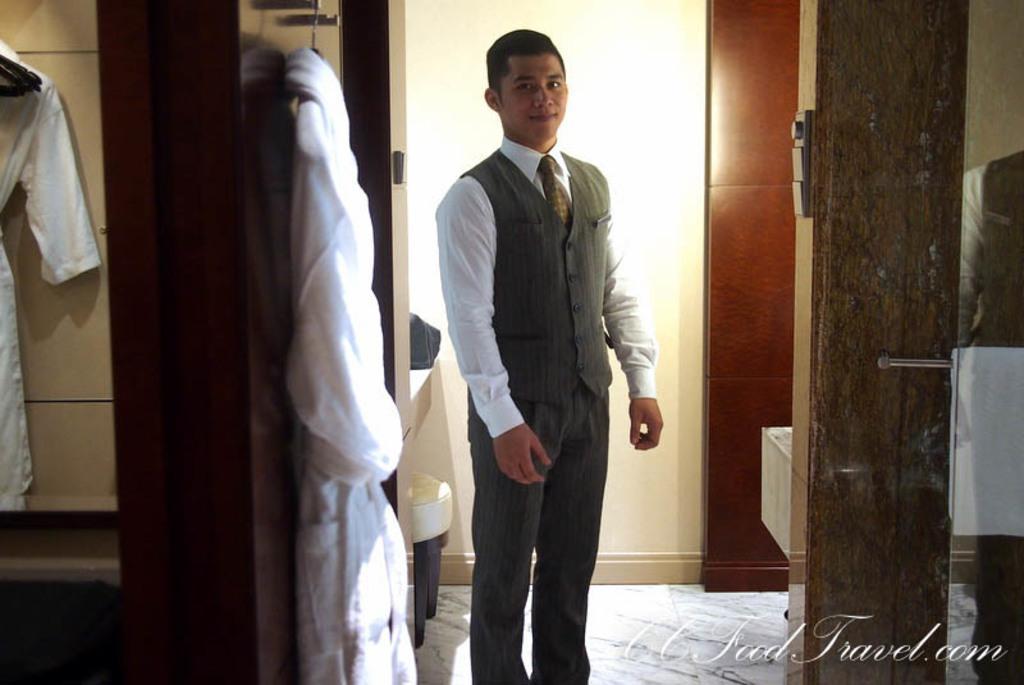In one or two sentences, can you explain what this image depicts? In this image I can see one person is standing and wearing white and grey color dress. I can see the wall, few clothes are hanged to some objects. 